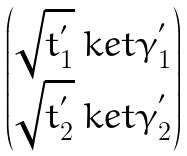Convert formula to latex. <formula><loc_0><loc_0><loc_500><loc_500>\begin{pmatrix} \sqrt { t _ { 1 } ^ { ^ { \prime } } } \ k e t { \gamma _ { 1 } ^ { ^ { \prime } } } \\ \sqrt { t _ { 2 } ^ { ^ { \prime } } } \ k e t { \gamma _ { 2 } ^ { ^ { \prime } } } \end{pmatrix}</formula> 